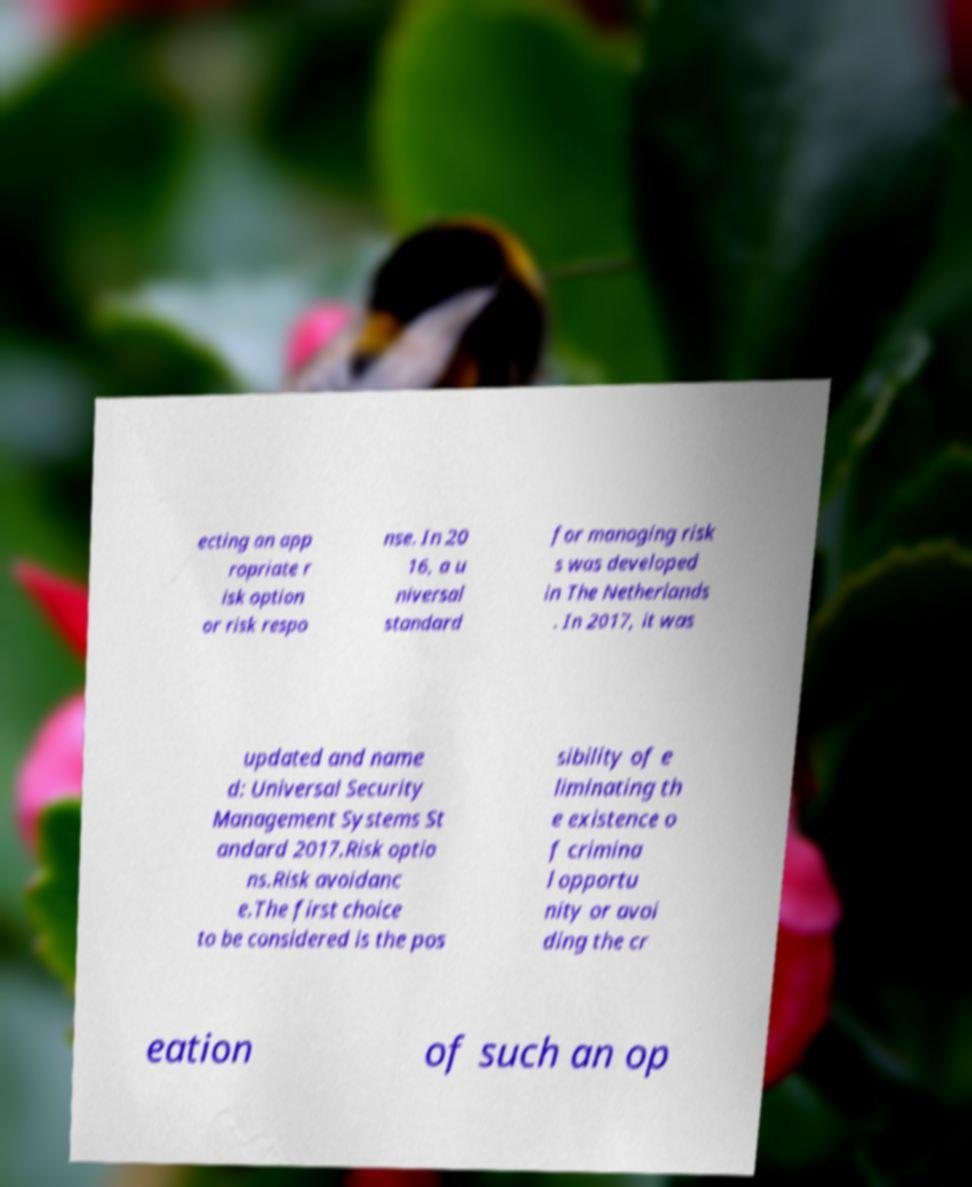Can you accurately transcribe the text from the provided image for me? ecting an app ropriate r isk option or risk respo nse. In 20 16, a u niversal standard for managing risk s was developed in The Netherlands . In 2017, it was updated and name d: Universal Security Management Systems St andard 2017.Risk optio ns.Risk avoidanc e.The first choice to be considered is the pos sibility of e liminating th e existence o f crimina l opportu nity or avoi ding the cr eation of such an op 